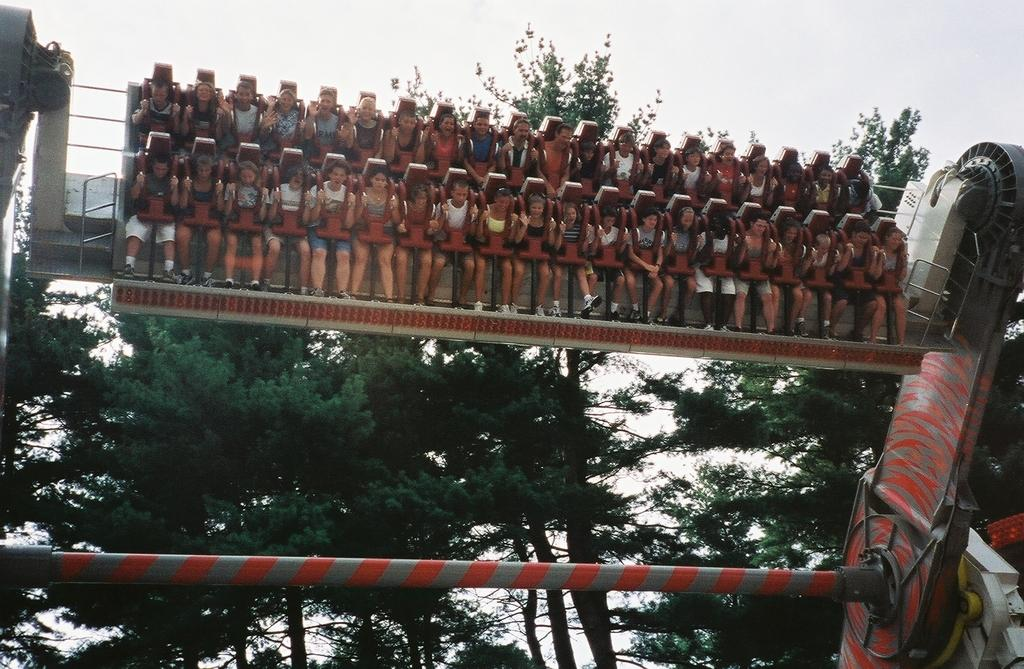What is the main subject of the image? There is an amusement park ride in the image. Are there any people on the ride? Yes, people are sitting on the ride. What can be seen in the background of the image? There are trees visible in the background of the image. What type of surprise can be seen on the thumb of the person sitting on the ride? There is no thumb or surprise present in the image; it only features an amusement park ride and people sitting on it. 